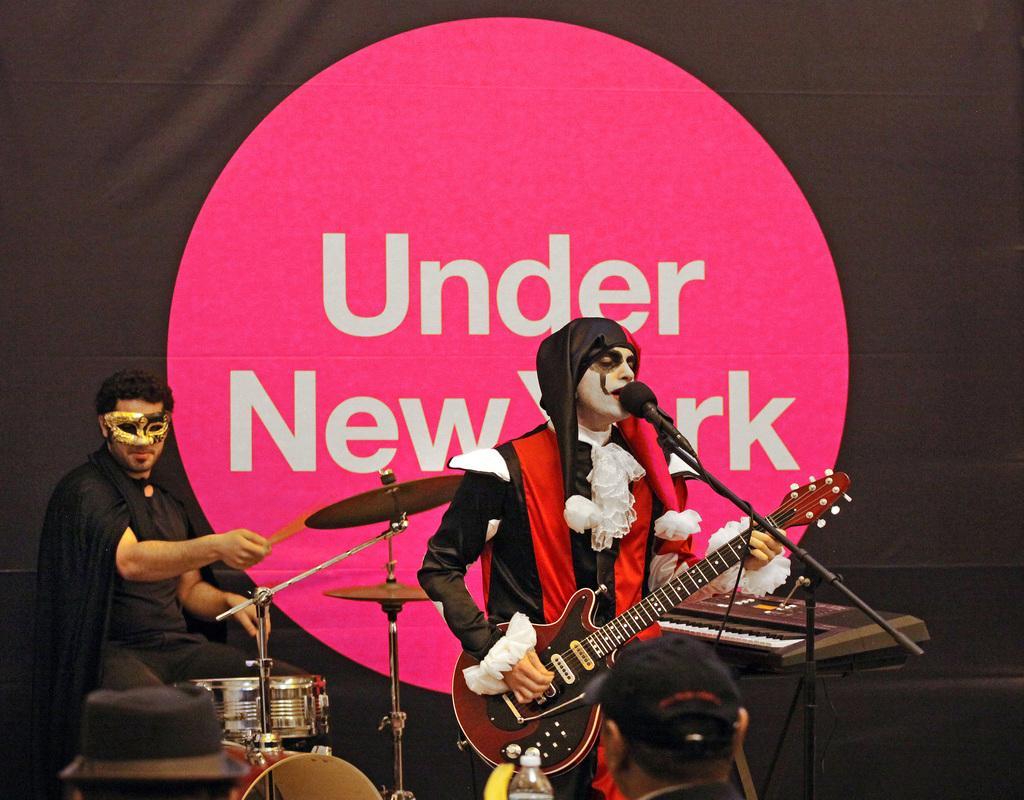Could you give a brief overview of what you see in this image? In this picture there are two people sitting on the chairs and playing some musical instruments and behind them there is a posture in black and pink color on which there is written under new York. 